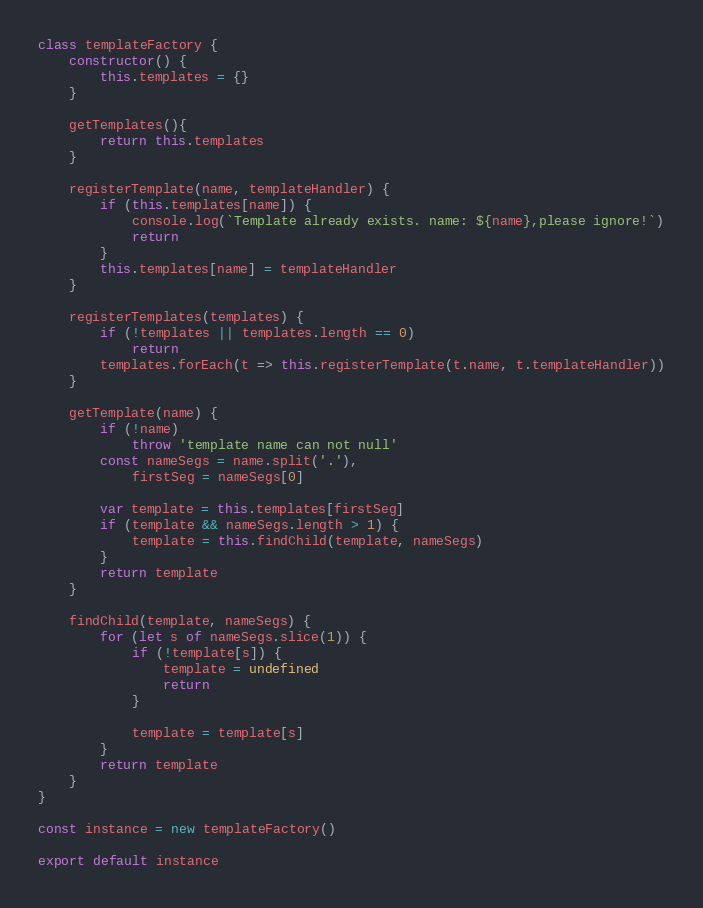Convert code to text. <code><loc_0><loc_0><loc_500><loc_500><_JavaScript_>class templateFactory {
    constructor() {
        this.templates = {}
    }

    getTemplates(){
        return this.templates
    }
    
    registerTemplate(name, templateHandler) {
        if (this.templates[name]) {
            console.log(`Template already exists. name: ${name},please ignore!`)
            return
        }
        this.templates[name] = templateHandler
    }

    registerTemplates(templates) {
        if (!templates || templates.length == 0)
            return
        templates.forEach(t => this.registerTemplate(t.name, t.templateHandler))
    }

    getTemplate(name) {
        if (!name)
            throw 'template name can not null'
        const nameSegs = name.split('.'),
            firstSeg = nameSegs[0]

        var template = this.templates[firstSeg]
        if (template && nameSegs.length > 1) {
            template = this.findChild(template, nameSegs)
        }
        return template
    }

    findChild(template, nameSegs) {
        for (let s of nameSegs.slice(1)) {
            if (!template[s]) {
                template = undefined
                return
            }

            template = template[s]
        }
        return template
    }
}

const instance = new templateFactory()

export default instance</code> 